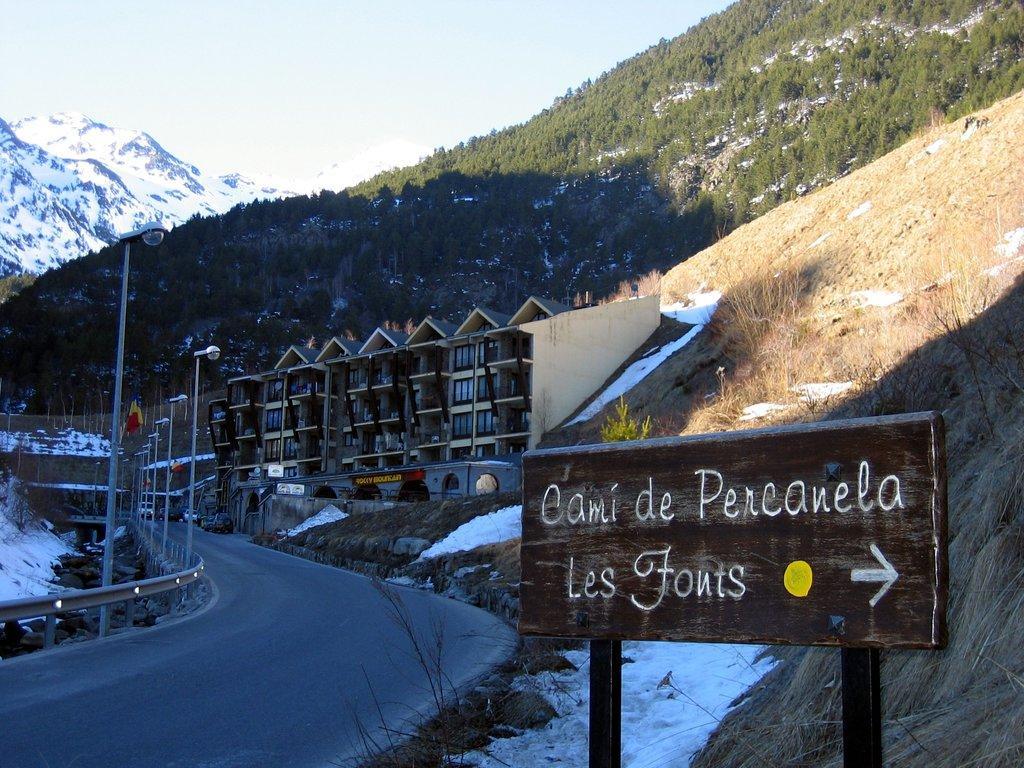Please provide a concise description of this image. As we can see in the image there is sign board, street lamps, snow, buildings, hills and trees. At the top there is sky. 